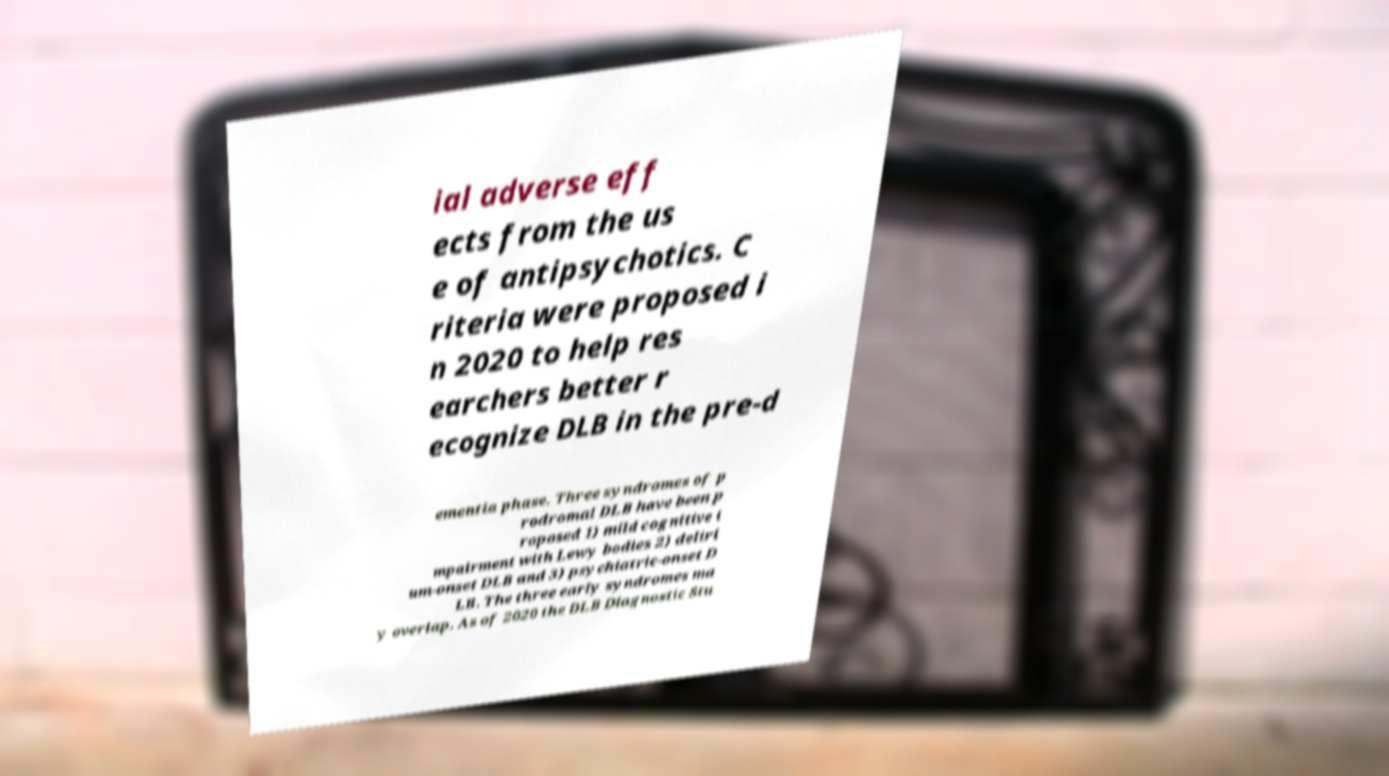Could you extract and type out the text from this image? ial adverse eff ects from the us e of antipsychotics. C riteria were proposed i n 2020 to help res earchers better r ecognize DLB in the pre-d ementia phase. Three syndromes of p rodromal DLB have been p roposed 1) mild cognitive i mpairment with Lewy bodies 2) deliri um-onset DLB and 3) psychiatric-onset D LB. The three early syndromes ma y overlap. As of 2020 the DLB Diagnostic Stu 